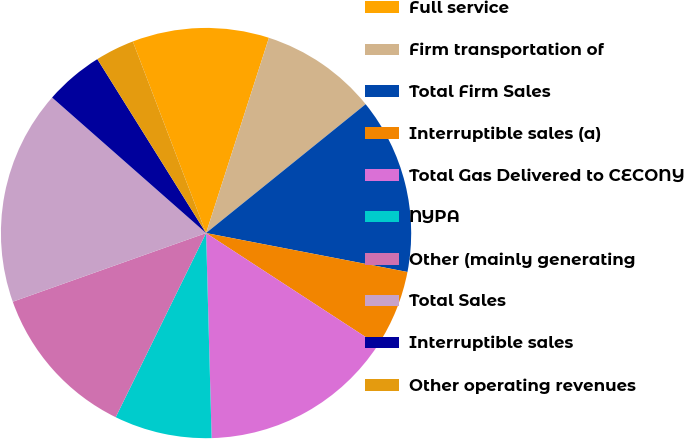<chart> <loc_0><loc_0><loc_500><loc_500><pie_chart><fcel>Full service<fcel>Firm transportation of<fcel>Total Firm Sales<fcel>Interruptible sales (a)<fcel>Total Gas Delivered to CECONY<fcel>NYPA<fcel>Other (mainly generating<fcel>Total Sales<fcel>Interruptible sales<fcel>Other operating revenues<nl><fcel>10.77%<fcel>9.23%<fcel>13.85%<fcel>6.15%<fcel>15.38%<fcel>7.69%<fcel>12.31%<fcel>16.92%<fcel>4.62%<fcel>3.08%<nl></chart> 